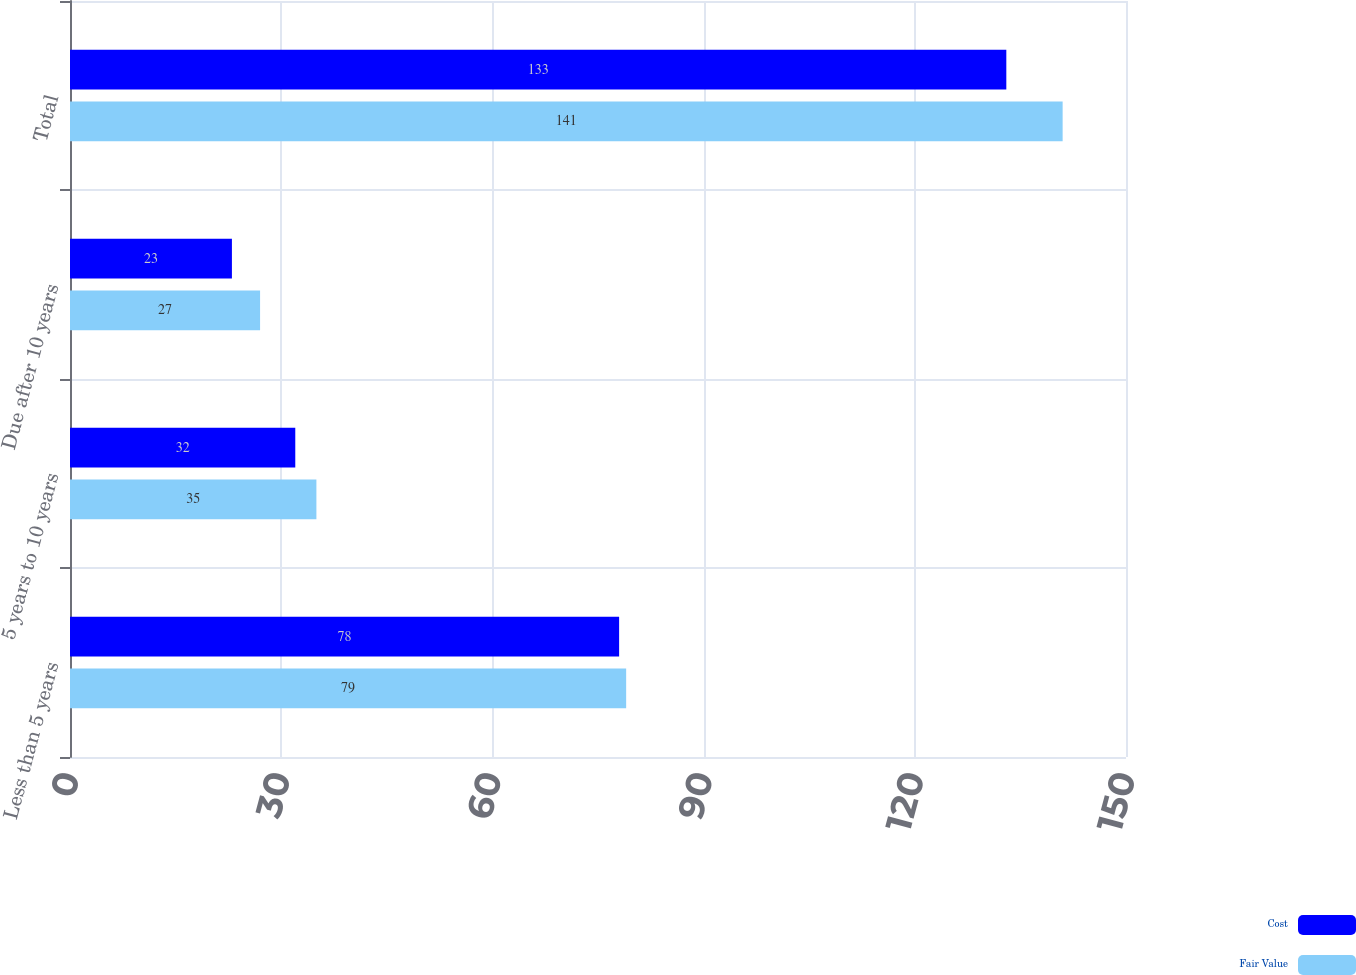<chart> <loc_0><loc_0><loc_500><loc_500><stacked_bar_chart><ecel><fcel>Less than 5 years<fcel>5 years to 10 years<fcel>Due after 10 years<fcel>Total<nl><fcel>Cost<fcel>78<fcel>32<fcel>23<fcel>133<nl><fcel>Fair Value<fcel>79<fcel>35<fcel>27<fcel>141<nl></chart> 